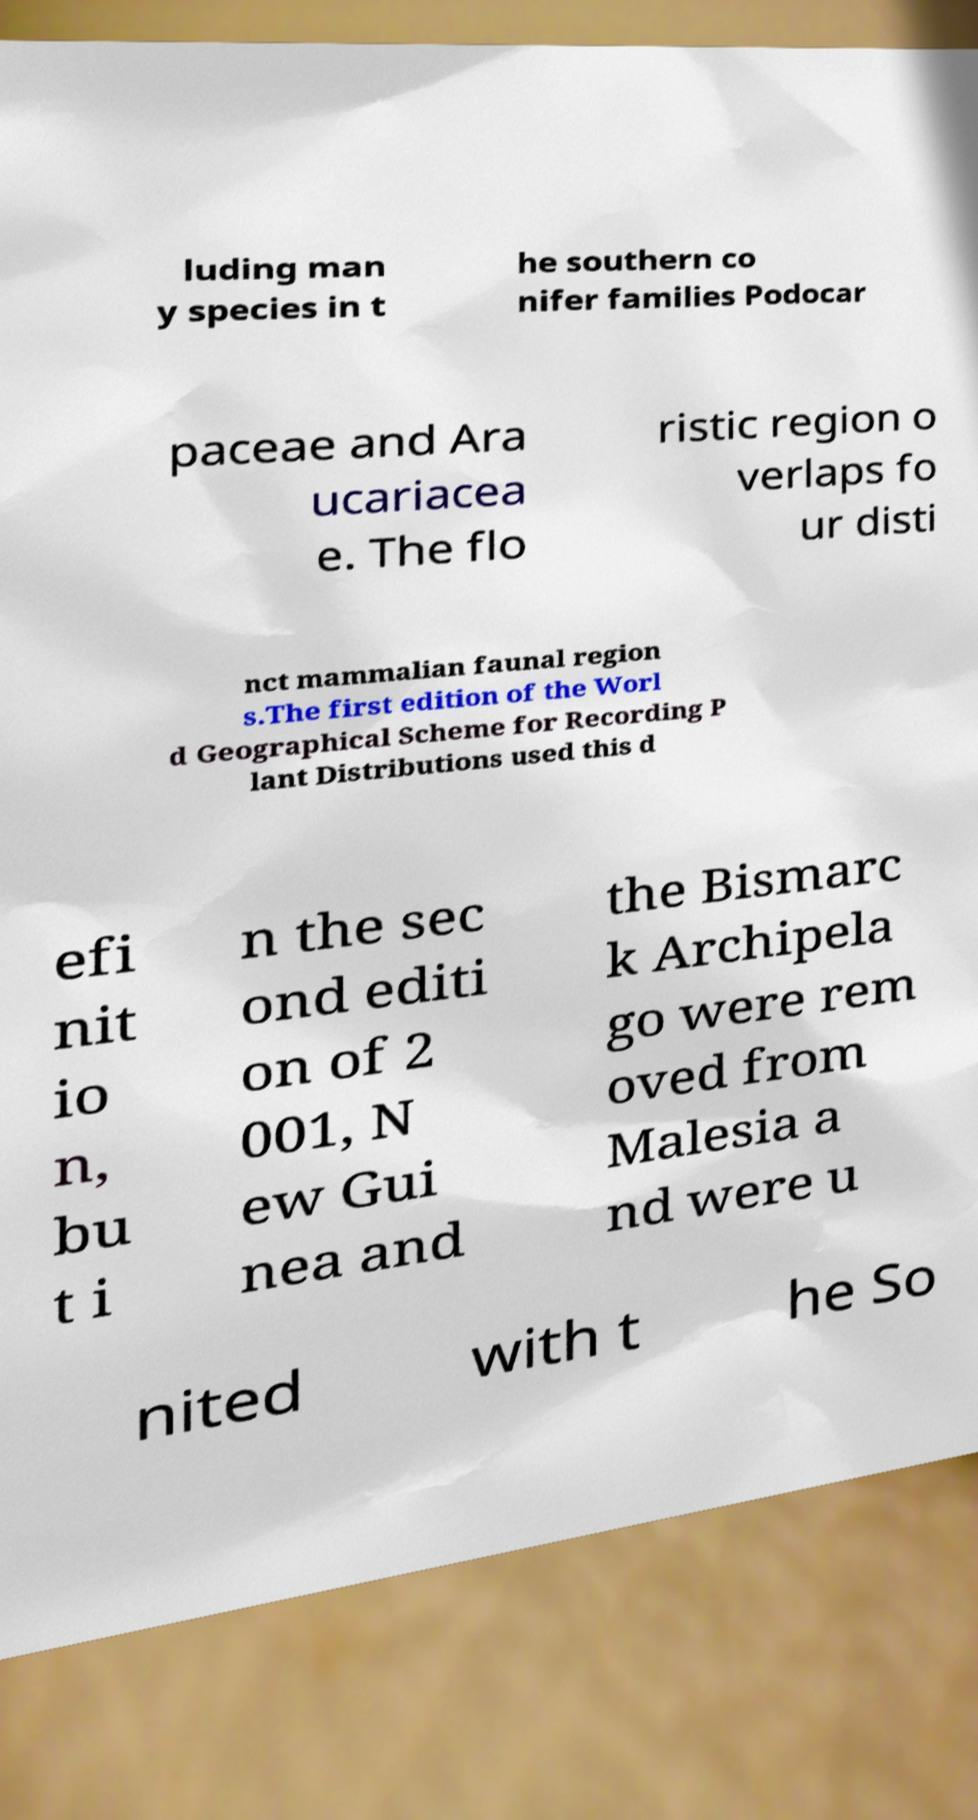Can you accurately transcribe the text from the provided image for me? luding man y species in t he southern co nifer families Podocar paceae and Ara ucariacea e. The flo ristic region o verlaps fo ur disti nct mammalian faunal region s.The first edition of the Worl d Geographical Scheme for Recording P lant Distributions used this d efi nit io n, bu t i n the sec ond editi on of 2 001, N ew Gui nea and the Bismarc k Archipela go were rem oved from Malesia a nd were u nited with t he So 